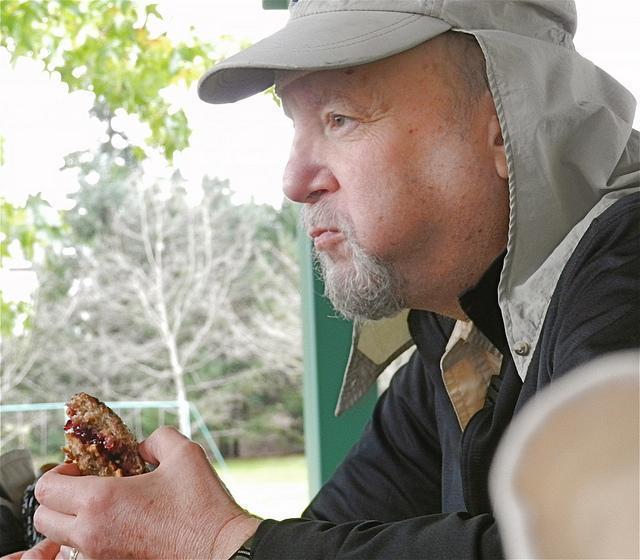How many people are there?
Give a very brief answer. 1. 